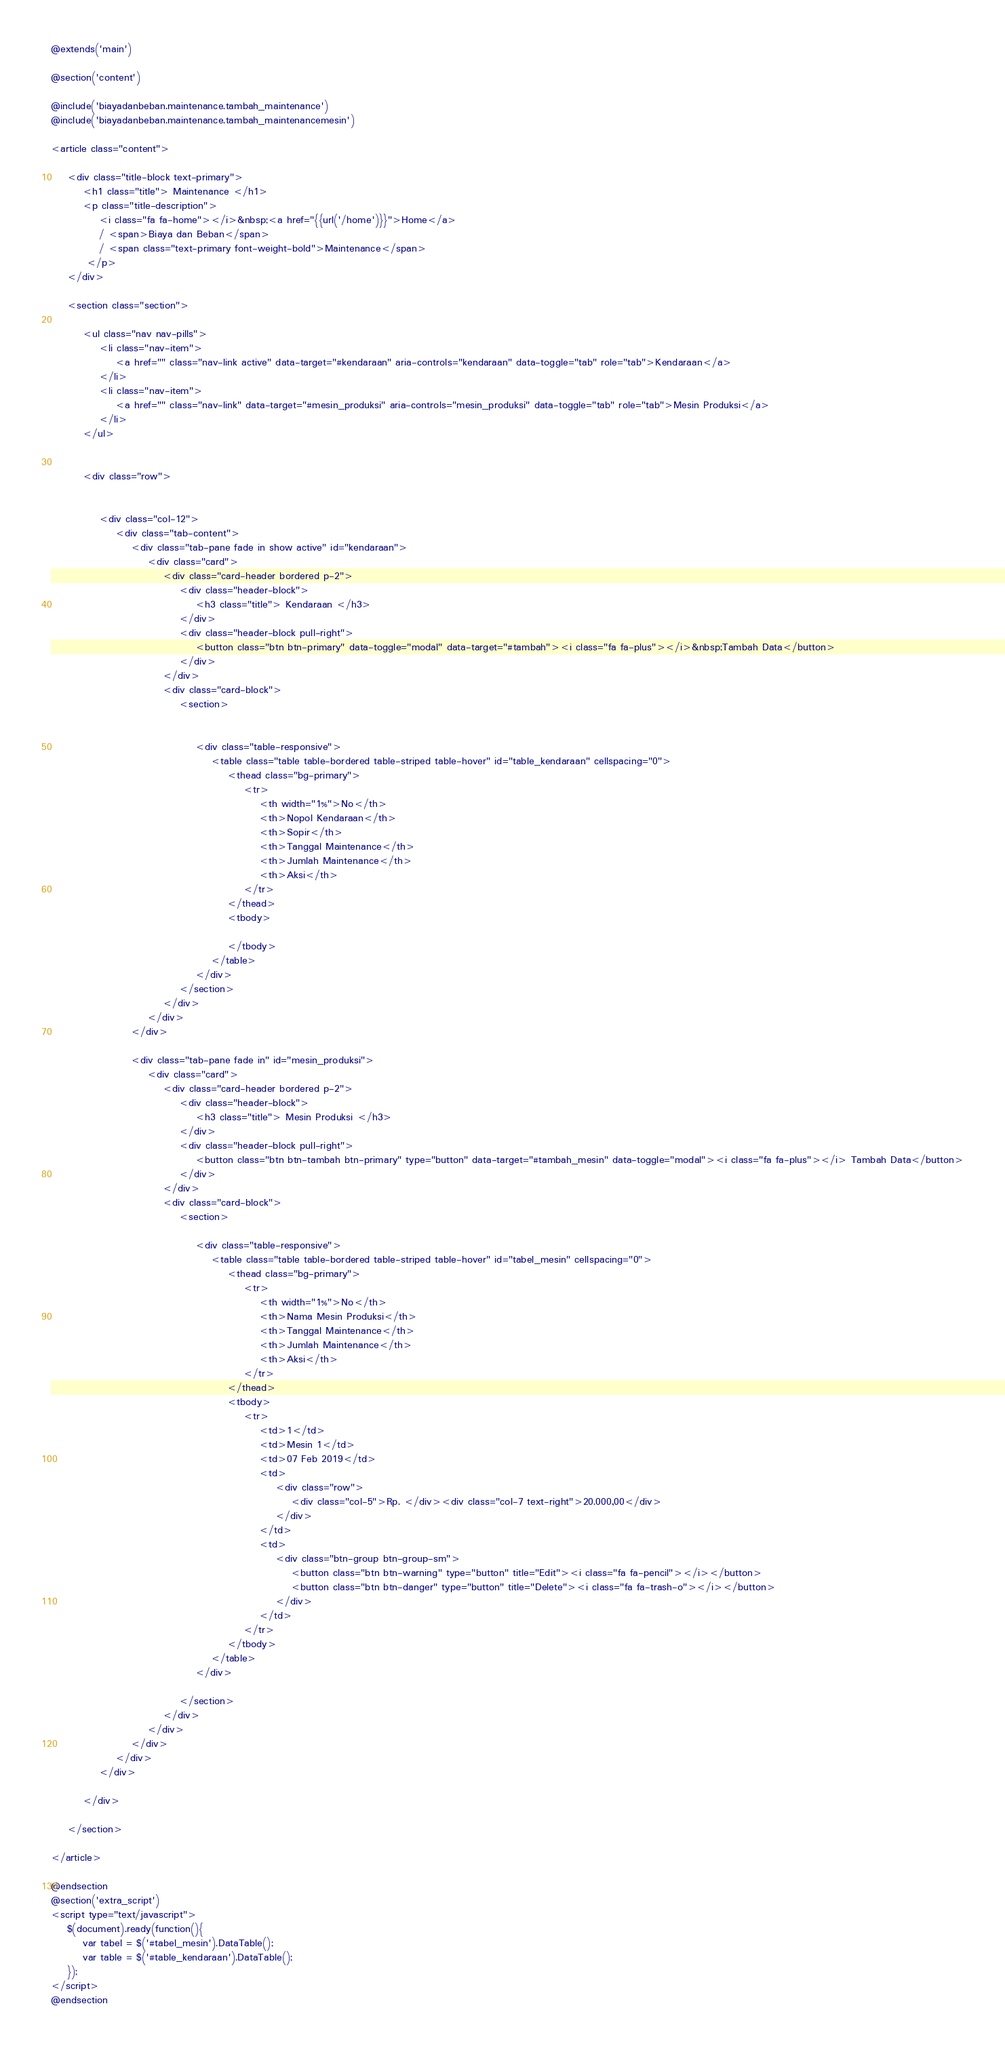Convert code to text. <code><loc_0><loc_0><loc_500><loc_500><_PHP_>@extends('main')

@section('content')

@include('biayadanbeban.maintenance.tambah_maintenance')
@include('biayadanbeban.maintenance.tambah_maintenancemesin')

<article class="content">

	<div class="title-block text-primary">
	    <h1 class="title"> Maintenance </h1>
	    <p class="title-description">
	    	<i class="fa fa-home"></i>&nbsp;<a href="{{url('/home')}}">Home</a> 
	    	/ <span>Biaya dan Beban</span> 
	    	/ <span class="text-primary font-weight-bold">Maintenance</span>
	     </p>
	</div>

	<section class="section">

		<ul class="nav nav-pills">
            <li class="nav-item">
                <a href="" class="nav-link active" data-target="#kendaraan" aria-controls="kendaraan" data-toggle="tab" role="tab">Kendaraan</a>
            </li>
            <li class="nav-item">
                <a href="" class="nav-link" data-target="#mesin_produksi" aria-controls="mesin_produksi" data-toggle="tab" role="tab">Mesin Produksi</a>
            </li>
        </ul>
		

		<div class="row">


			<div class="col-12">
				<div class="tab-content">
					<div class="tab-pane fade in show active" id="kendaraan">
						<div class="card">
		                    <div class="card-header bordered p-2">
		                    	<div class="header-block">
			                        <h3 class="title"> Kendaraan </h3>
			                    </div>
		                		<div class="header-block pull-right">
		                			<button class="btn btn-primary" data-toggle="modal" data-target="#tambah"><i class="fa fa-plus"></i>&nbsp;Tambah Data</button>
		                		</div>
		                    </div>
			                <div class="card-block">
			                    <section>
			                    	
			                    	
			                    	<div class="table-responsive">
			                            <table class="table table-bordered table-striped table-hover" id="table_kendaraan" cellspacing="0">
			                                <thead class="bg-primary">
			                                    <tr>
			                                    	<th width="1%">No</th>
									                <th>Nopol Kendaraan</th>
									                <th>Sopir</th>
									                <th>Tanggal Maintenance</th>
									                <th>Jumlah Maintenance</th>
									                <th>Aksi</th>
									            </tr>
			                                </thead>
			                                <tbody>

									        </tbody>
			                            </table>
			                        </div>
			                    </section>
			                </div>
			            </div>
			        </div>

			        <div class="tab-pane fade in" id="mesin_produksi">
						<div class="card">
		                    <div class="card-header bordered p-2">
		                    	<div class="header-block">
			                        <h3 class="title"> Mesin Produksi </h3>
			                    </div>
			                    <div class="header-block pull-right">
			                    	<button class="btn btn-tambah btn-primary" type="button" data-target="#tambah_mesin" data-toggle="modal"><i class="fa fa-plus"></i> Tambah Data</button>
			                    </div>
		                    </div>
			                <div class="card-block">
			                    <section>

			                    	<div class="table-responsive">
			                            <table class="table table-bordered table-striped table-hover" id="tabel_mesin" cellspacing="0">
			                                <thead class="bg-primary">
			                                    <tr>
			                                    	<th width="1%">No</th>
									                <th>Nama Mesin Produksi</th>
									                <th>Tanggal Maintenance</th>
									                <th>Jumlah Maintenance</th>
									                <th>Aksi</th>
									            </tr>
			                                </thead>
			                                <tbody>
			                                	<tr>
			                                		<td>1</td>
			                                		<td>Mesin 1</td>
			                                		<td>07 Feb 2019</td>
			                                		<td>
			                                			<div class="row">
			                                				<div class="col-5">Rp. </div><div class="col-7 text-right">20.000,00</div>
			                                			</div>
			                                		</td>
			                                		<td>
			                                			<div class="btn-group btn-group-sm">
			                                				<button class="btn btn-warning" type="button" title="Edit"><i class="fa fa-pencil"></i></button>
			                                				<button class="btn btn-danger" type="button" title="Delete"><i class="fa fa-trash-o"></i></button>
			                                			</div>
			                                		</td>
			                                	</tr>
									        </tbody>
			                            </table>
			                        </div>
			                		
			                    </section>
			                </div>
			            </div>
			        </div>
		        </div>
			</div>

		</div>

	</section>

</article>

@endsection
@section('extra_script')
<script type="text/javascript">
	$(document).ready(function(){
		var tabel = $('#tabel_mesin').DataTable();
		var table = $('#table_kendaraan').DataTable();
	});
</script>
@endsection</code> 